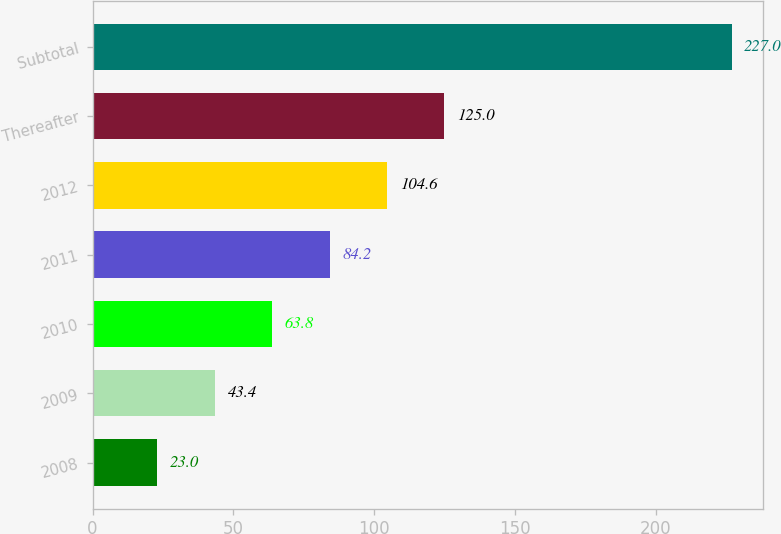<chart> <loc_0><loc_0><loc_500><loc_500><bar_chart><fcel>2008<fcel>2009<fcel>2010<fcel>2011<fcel>2012<fcel>Thereafter<fcel>Subtotal<nl><fcel>23<fcel>43.4<fcel>63.8<fcel>84.2<fcel>104.6<fcel>125<fcel>227<nl></chart> 